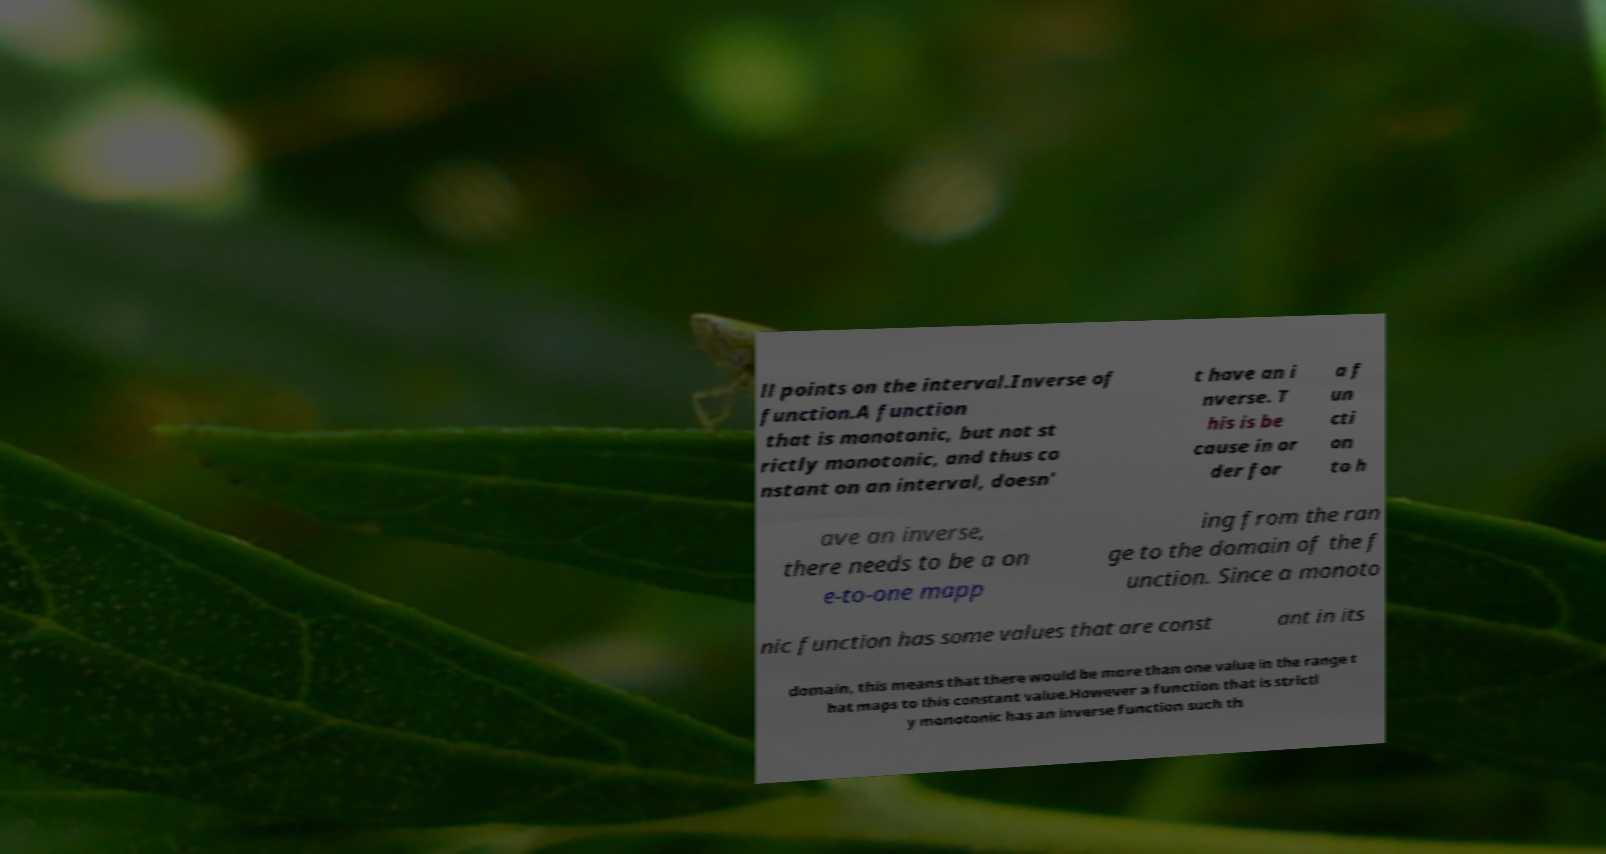Please identify and transcribe the text found in this image. ll points on the interval.Inverse of function.A function that is monotonic, but not st rictly monotonic, and thus co nstant on an interval, doesn' t have an i nverse. T his is be cause in or der for a f un cti on to h ave an inverse, there needs to be a on e-to-one mapp ing from the ran ge to the domain of the f unction. Since a monoto nic function has some values that are const ant in its domain, this means that there would be more than one value in the range t hat maps to this constant value.However a function that is strictl y monotonic has an inverse function such th 